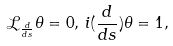<formula> <loc_0><loc_0><loc_500><loc_500>\mathcal { L } _ { \frac { d } { d s } } \theta = 0 , \, i ( \frac { d } { d s } ) \theta = 1 ,</formula> 